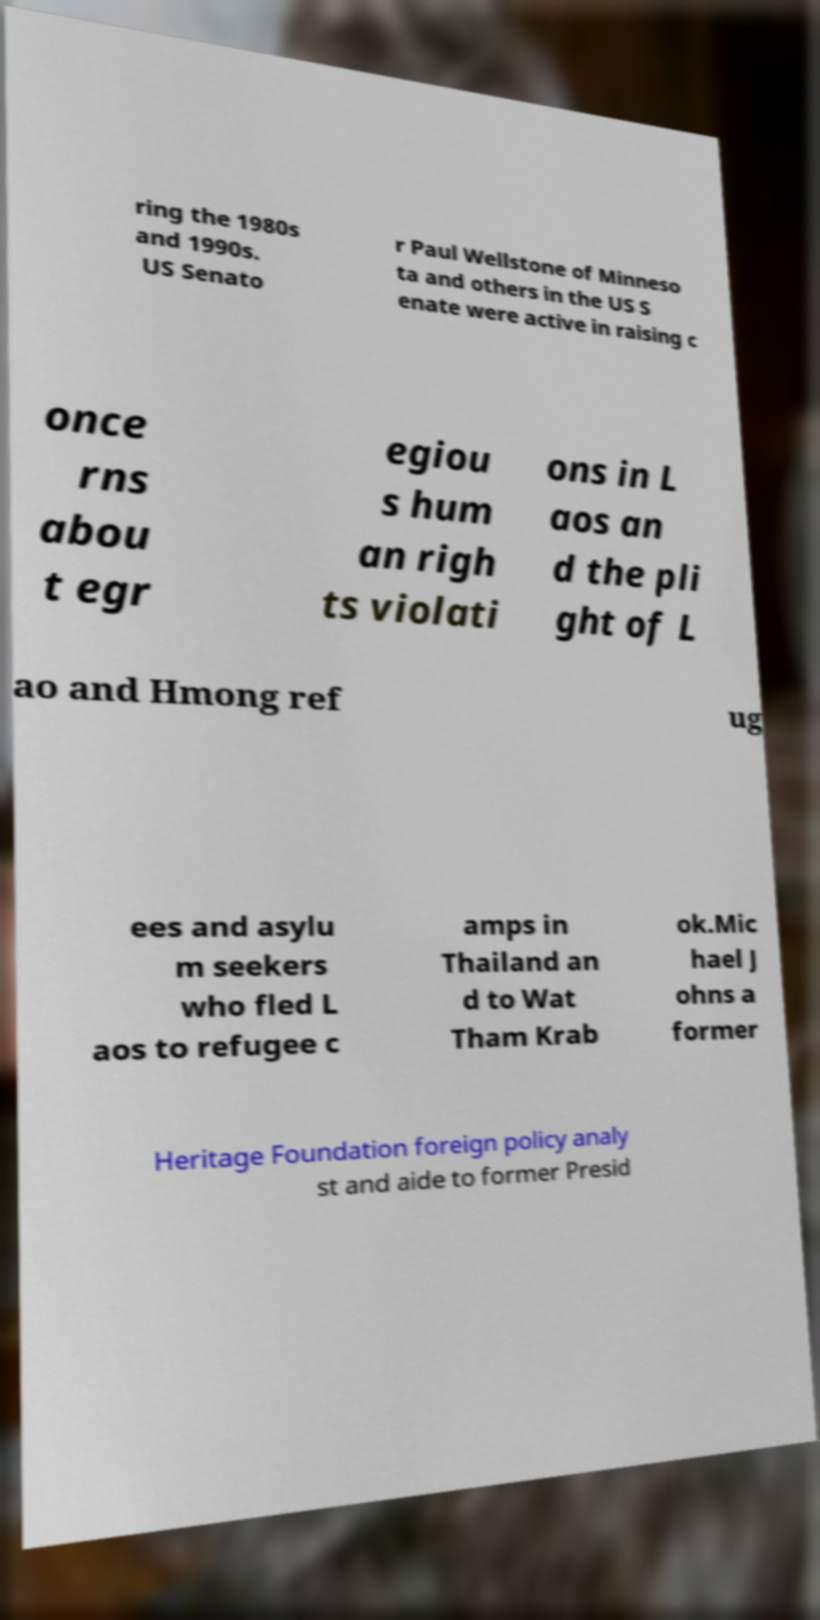For documentation purposes, I need the text within this image transcribed. Could you provide that? ring the 1980s and 1990s. US Senato r Paul Wellstone of Minneso ta and others in the US S enate were active in raising c once rns abou t egr egiou s hum an righ ts violati ons in L aos an d the pli ght of L ao and Hmong ref ug ees and asylu m seekers who fled L aos to refugee c amps in Thailand an d to Wat Tham Krab ok.Mic hael J ohns a former Heritage Foundation foreign policy analy st and aide to former Presid 